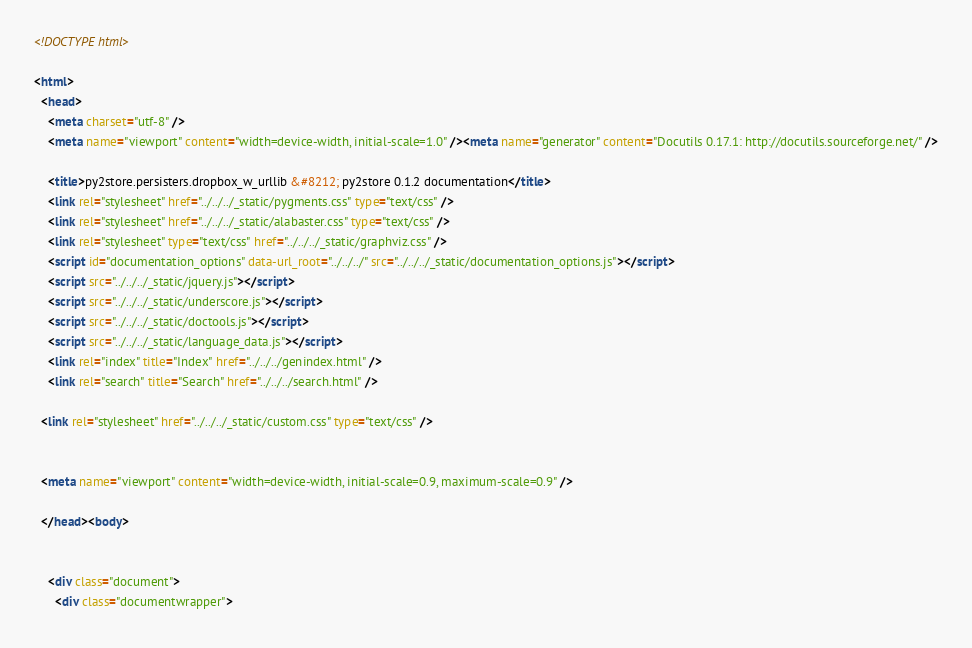Convert code to text. <code><loc_0><loc_0><loc_500><loc_500><_HTML_>
<!DOCTYPE html>

<html>
  <head>
    <meta charset="utf-8" />
    <meta name="viewport" content="width=device-width, initial-scale=1.0" /><meta name="generator" content="Docutils 0.17.1: http://docutils.sourceforge.net/" />

    <title>py2store.persisters.dropbox_w_urllib &#8212; py2store 0.1.2 documentation</title>
    <link rel="stylesheet" href="../../../_static/pygments.css" type="text/css" />
    <link rel="stylesheet" href="../../../_static/alabaster.css" type="text/css" />
    <link rel="stylesheet" type="text/css" href="../../../_static/graphviz.css" />
    <script id="documentation_options" data-url_root="../../../" src="../../../_static/documentation_options.js"></script>
    <script src="../../../_static/jquery.js"></script>
    <script src="../../../_static/underscore.js"></script>
    <script src="../../../_static/doctools.js"></script>
    <script src="../../../_static/language_data.js"></script>
    <link rel="index" title="Index" href="../../../genindex.html" />
    <link rel="search" title="Search" href="../../../search.html" />
   
  <link rel="stylesheet" href="../../../_static/custom.css" type="text/css" />
  
  
  <meta name="viewport" content="width=device-width, initial-scale=0.9, maximum-scale=0.9" />

  </head><body>
  

    <div class="document">
      <div class="documentwrapper"></code> 